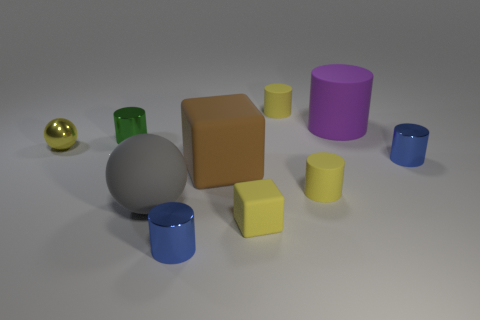How many yellow things are both in front of the brown cube and right of the yellow matte cube?
Your answer should be compact. 1. What number of other objects are the same size as the matte sphere?
Ensure brevity in your answer.  2. Is the size of the yellow matte cylinder that is in front of the green shiny cylinder the same as the blue thing on the right side of the large purple cylinder?
Make the answer very short. Yes. What number of objects are either large gray things or yellow rubber objects behind the big rubber ball?
Provide a succinct answer. 3. There is a sphere that is right of the tiny green shiny cylinder; how big is it?
Ensure brevity in your answer.  Large. Are there fewer tiny blocks behind the large brown matte thing than yellow spheres to the left of the green cylinder?
Provide a short and direct response. Yes. What is the yellow thing that is on the right side of the small yellow rubber block and in front of the big purple rubber thing made of?
Offer a very short reply. Rubber. What is the shape of the blue object that is on the right side of the tiny matte object behind the yellow metal sphere?
Provide a short and direct response. Cylinder. Do the tiny sphere and the small matte cube have the same color?
Your answer should be compact. Yes. How many yellow things are small rubber cubes or metallic cylinders?
Offer a very short reply. 1. 